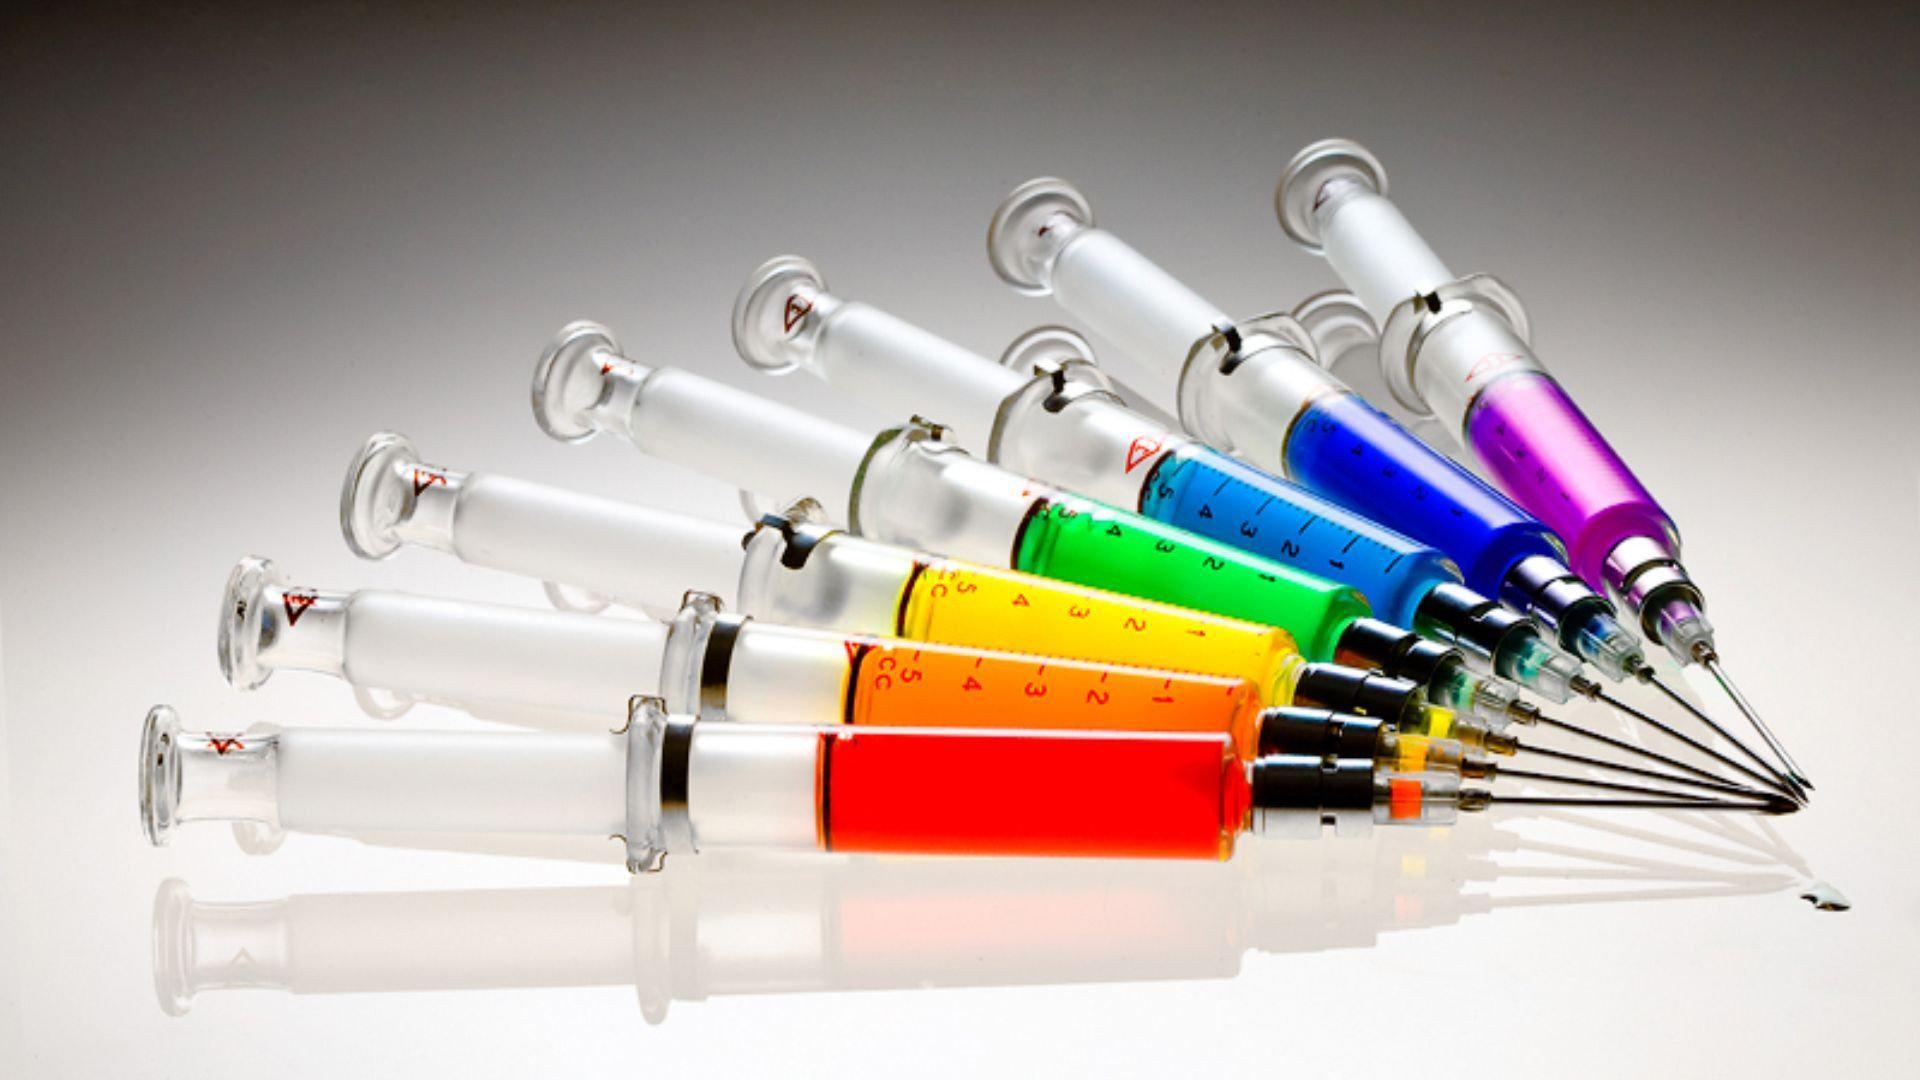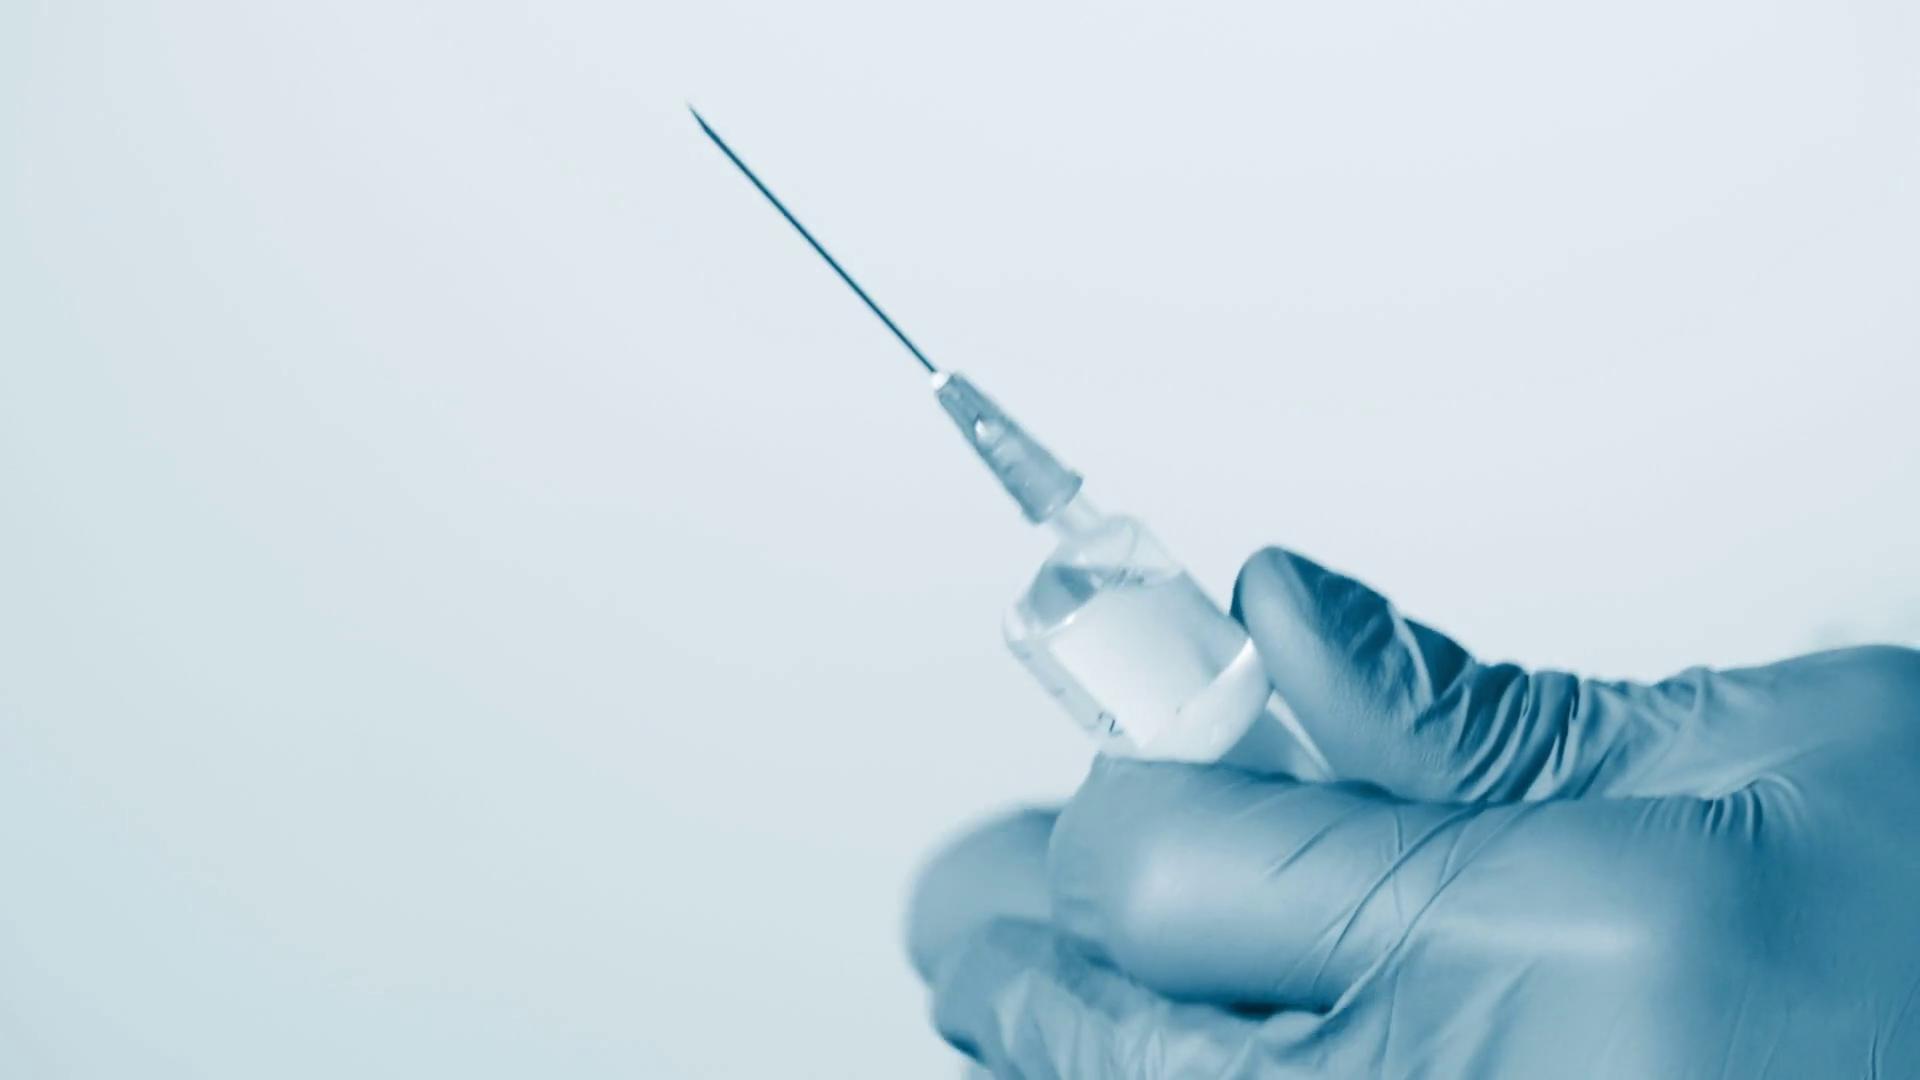The first image is the image on the left, the second image is the image on the right. Analyze the images presented: Is the assertion "In at least one image there is a single syringe being held pointing up and left." valid? Answer yes or no. Yes. 